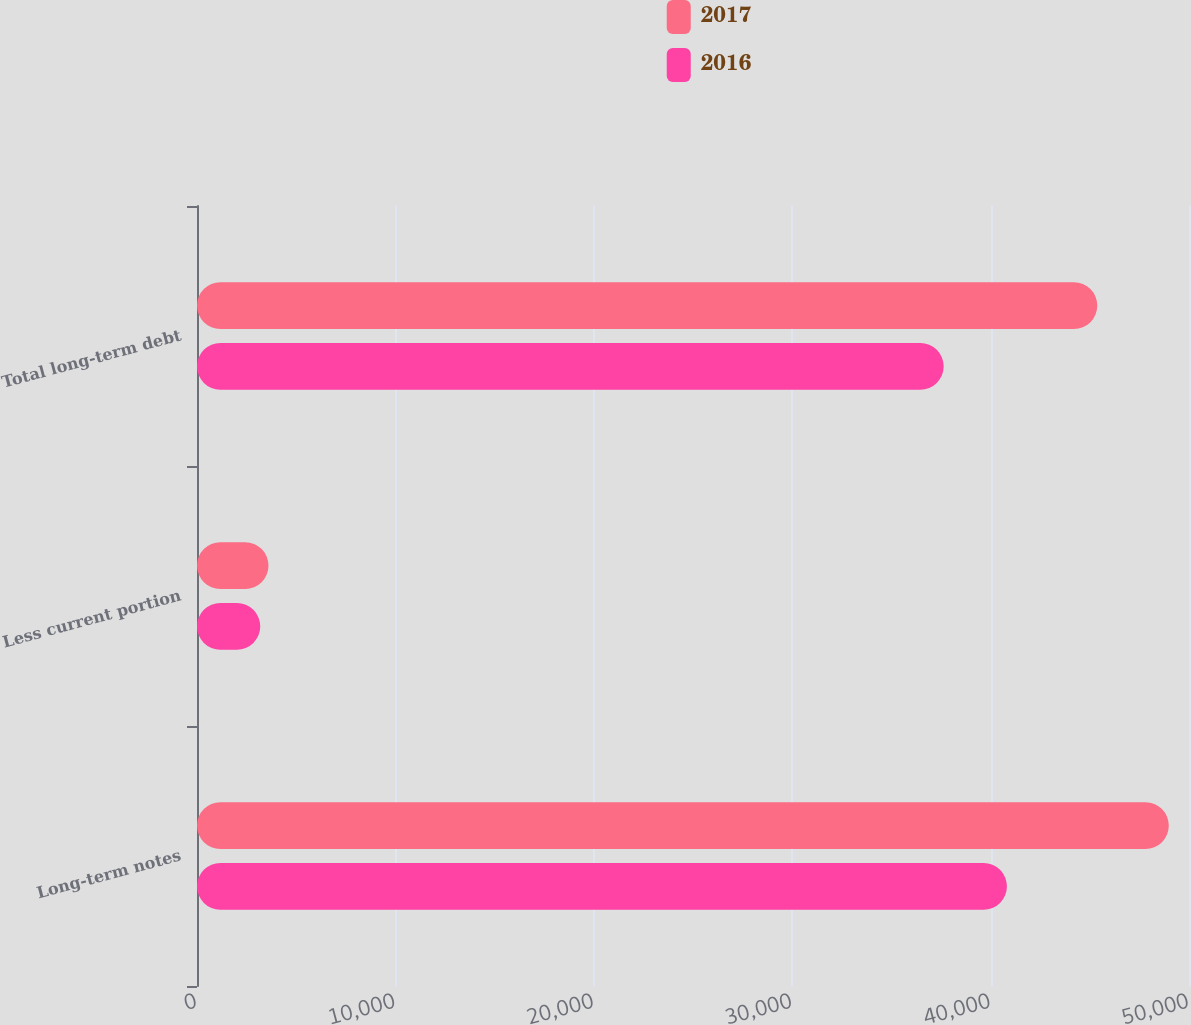Convert chart. <chart><loc_0><loc_0><loc_500><loc_500><stacked_bar_chart><ecel><fcel>Long-term notes<fcel>Less current portion<fcel>Total long-term debt<nl><fcel>2017<fcel>48982<fcel>3604<fcel>45378<nl><fcel>2016<fcel>40823<fcel>3188<fcel>37635<nl></chart> 